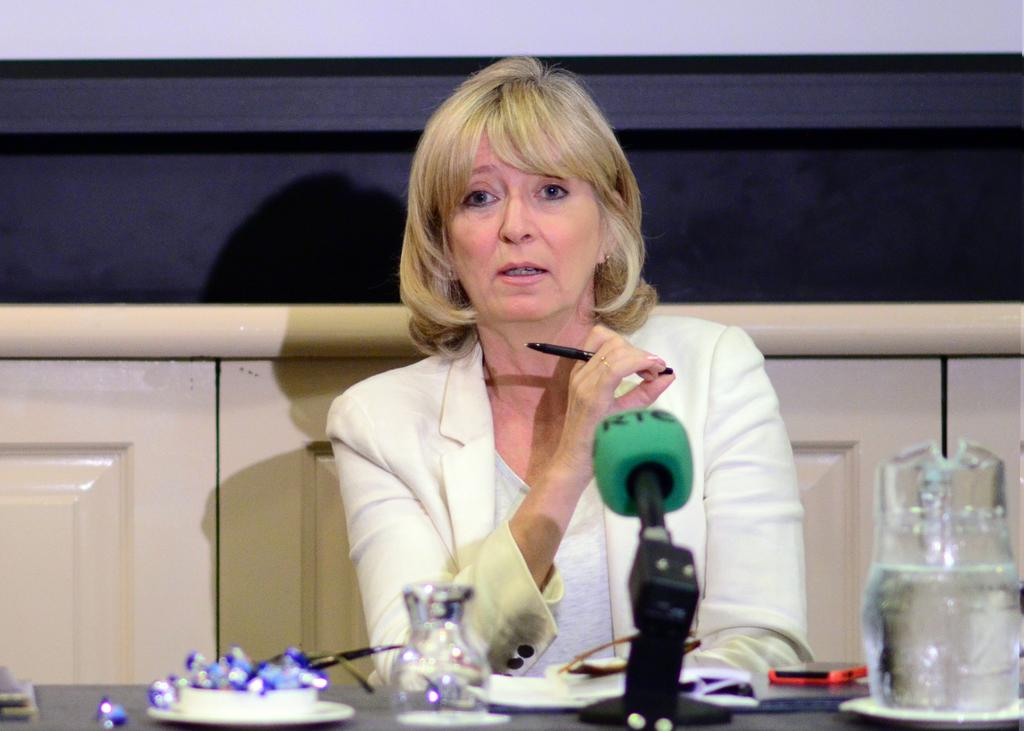<image>
Share a concise interpretation of the image provided. A blonde woman behind a mic that says RTC on it. 